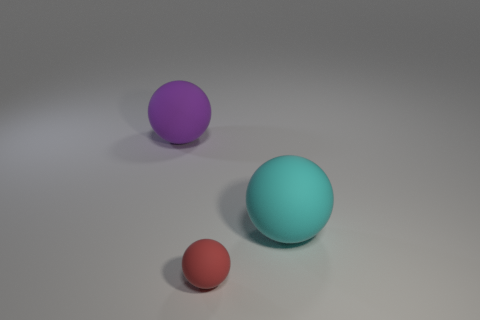Add 1 cyan matte spheres. How many objects exist? 4 Add 2 cyan shiny spheres. How many cyan shiny spheres exist? 2 Subtract 0 brown cubes. How many objects are left? 3 Subtract all small blue balls. Subtract all purple rubber objects. How many objects are left? 2 Add 3 red objects. How many red objects are left? 4 